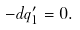Convert formula to latex. <formula><loc_0><loc_0><loc_500><loc_500>- d q ^ { \prime } _ { 1 } = 0 .</formula> 